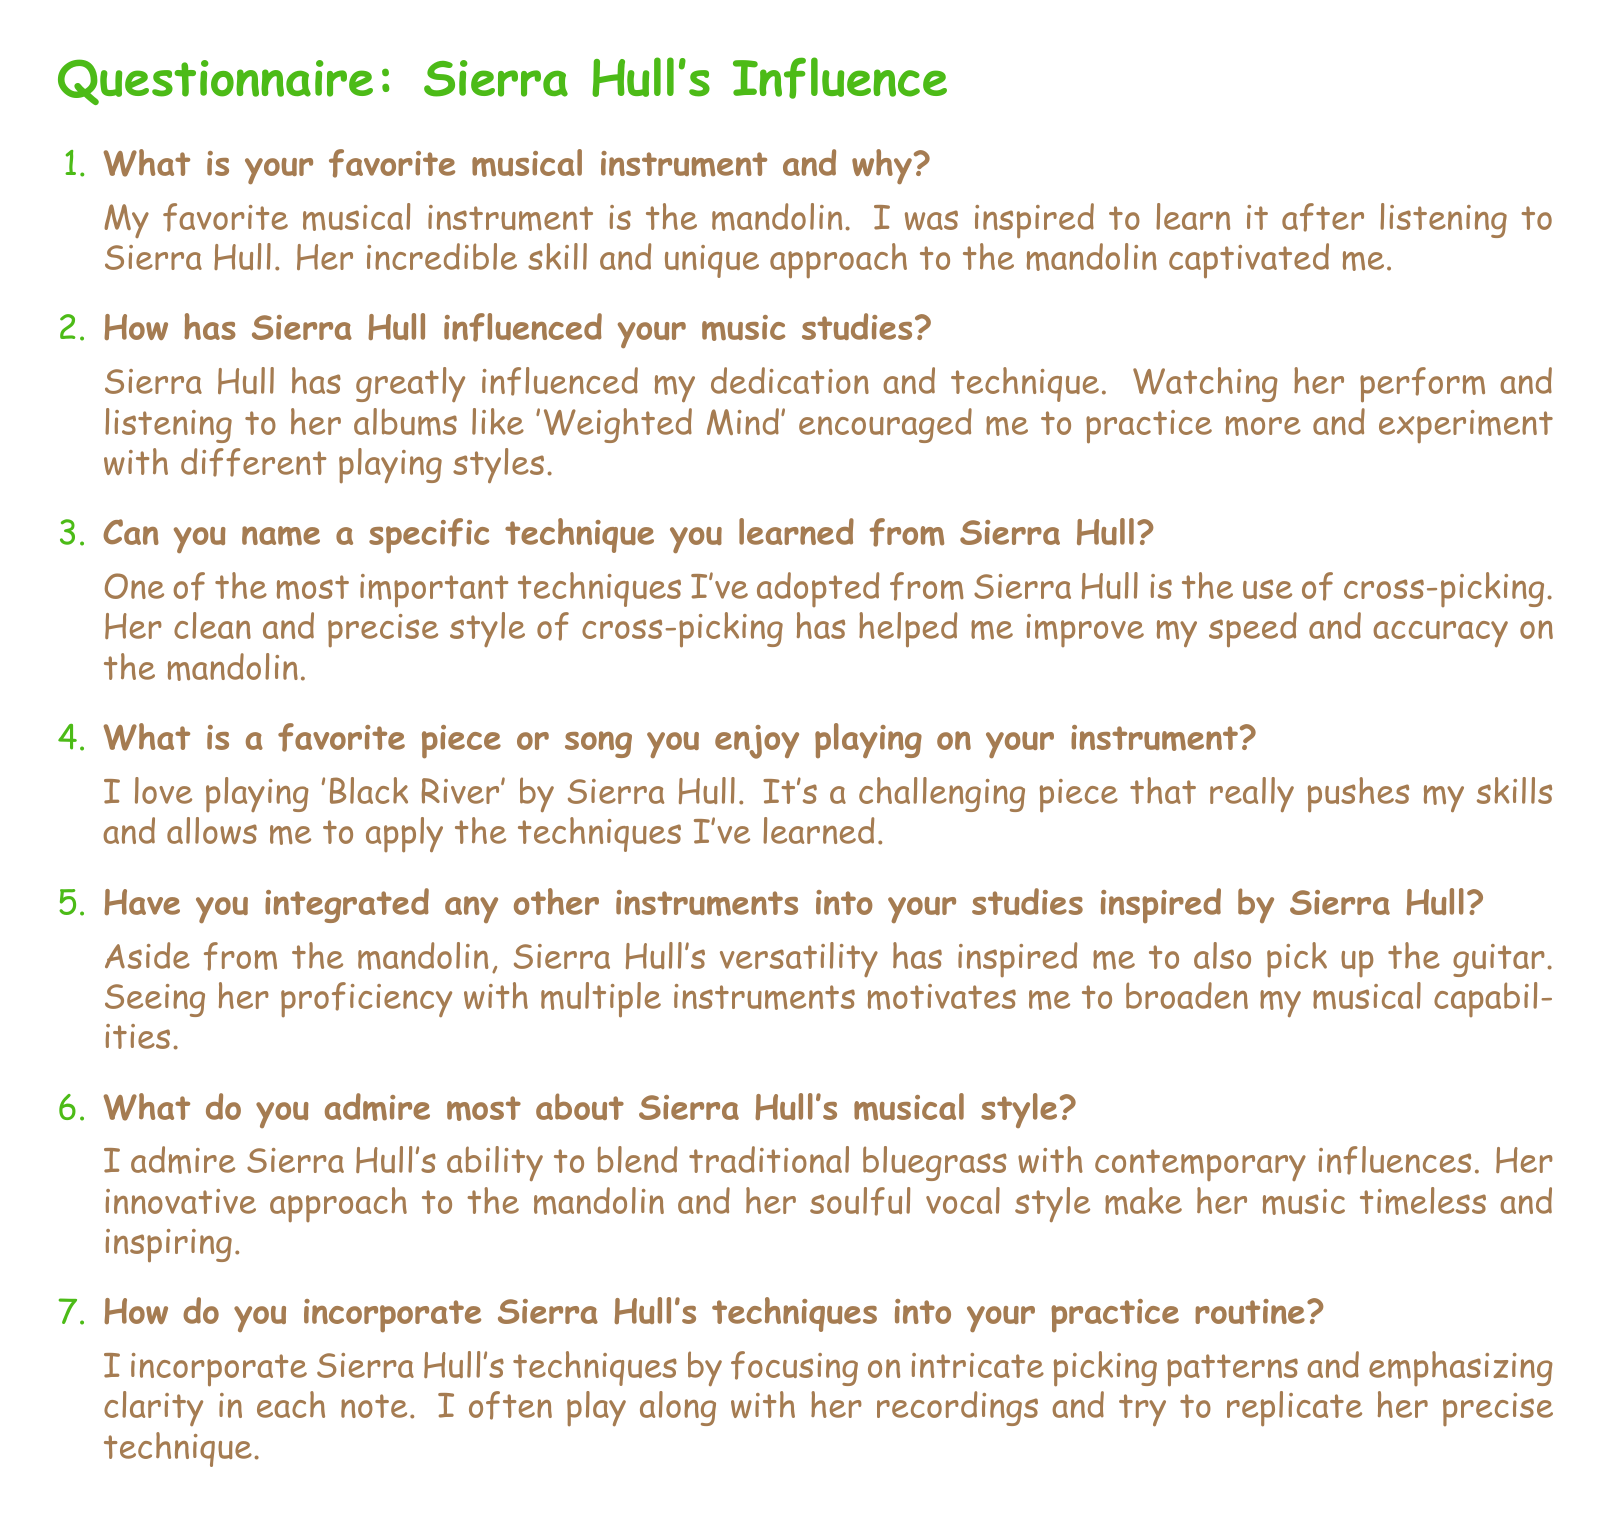What is the favorite musical instrument mentioned? The favorite musical instrument referred to in the document is explicitly stated as the mandolin.
Answer: mandolin Who inspired the author to learn the mandolin? The document directly indicates that Sierra Hull inspired the author to learn the mandolin through her skill and unique approach.
Answer: Sierra Hull What specific technique has the author learned from Sierra Hull? The author highlights the adoption of cross-picking as a specific technique influenced by Sierra Hull.
Answer: cross-picking What is the name of a song the author enjoys playing? The author mentions 'Black River' as a favorite piece to play on the mandolin.
Answer: Black River Which additional instrument did the author pick up inspired by Sierra Hull? The document states that the author has also picked up the guitar, influenced by Sierra Hull's versatility.
Answer: guitar What is one aspect of Sierra Hull's musical style that the author admires? The author expresses admiration for Sierra Hull's ability to blend traditional bluegrass with contemporary influences.
Answer: blending traditional bluegrass with contemporary influences How does the author practice Sierra Hull's techniques? The author incorporates techniques by focusing on intricate picking patterns and playing along with her recordings.
Answer: intricate picking patterns What is the title of Sierra Hull's album mentioned? The document references the album 'Weighted Mind' as influential in the author's music studies.
Answer: Weighted Mind What does the author aim to improve by practicing? The author aims to improve speed and accuracy on the mandolin through practicing techniques learned from Sierra Hull.
Answer: speed and accuracy 